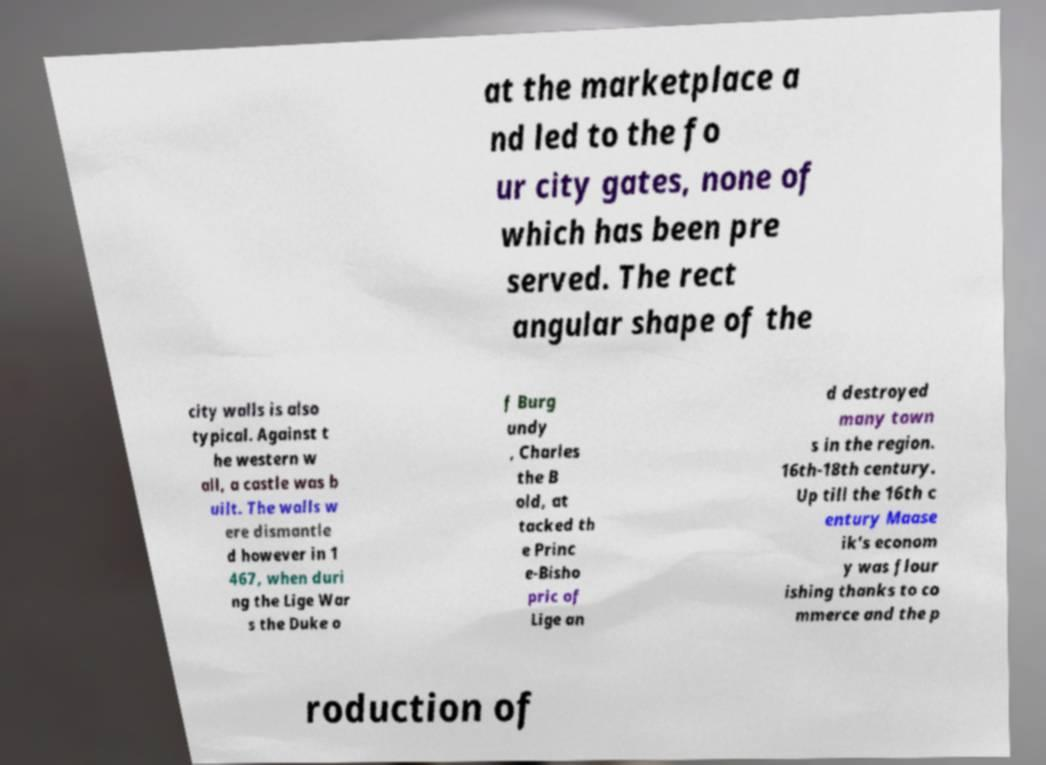Could you assist in decoding the text presented in this image and type it out clearly? at the marketplace a nd led to the fo ur city gates, none of which has been pre served. The rect angular shape of the city walls is also typical. Against t he western w all, a castle was b uilt. The walls w ere dismantle d however in 1 467, when duri ng the Lige War s the Duke o f Burg undy , Charles the B old, at tacked th e Princ e-Bisho pric of Lige an d destroyed many town s in the region. 16th-18th century. Up till the 16th c entury Maase ik's econom y was flour ishing thanks to co mmerce and the p roduction of 